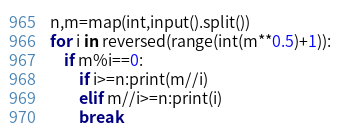Convert code to text. <code><loc_0><loc_0><loc_500><loc_500><_Python_>n,m=map(int,input().split())
for i in reversed(range(int(m**0.5)+1)):
    if m%i==0:
        if i>=n:print(m//i)
        elif m//i>=n:print(i)
        break</code> 